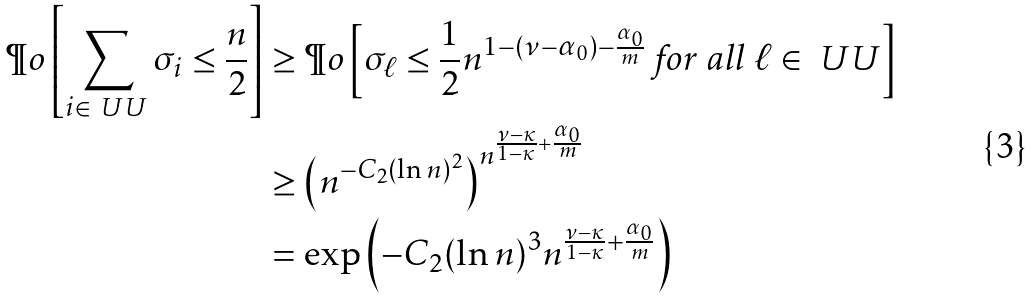<formula> <loc_0><loc_0><loc_500><loc_500>\P o \left [ \sum _ { i \in \ U U } \sigma _ { i } \leq \frac { n } { 2 } \right ] & \geq \P o \left [ \sigma _ { \ell } \leq \frac { 1 } { 2 } n ^ { 1 - ( \nu - \alpha _ { 0 } ) - \frac { \alpha _ { 0 } } { m } } \text { for all } \ell \in \ U U \right ] \\ & \geq \left ( n ^ { - C _ { 2 } ( \ln n ) ^ { 2 } } \right ) ^ { n ^ { \frac { \nu - \kappa } { 1 - \kappa } + \frac { \alpha _ { 0 } } { m } } } \\ & = \exp \left ( - C _ { 2 } ( \ln n ) ^ { 3 } n ^ { \frac { \nu - \kappa } { 1 - \kappa } + \frac { \alpha _ { 0 } } { m } } \right )</formula> 